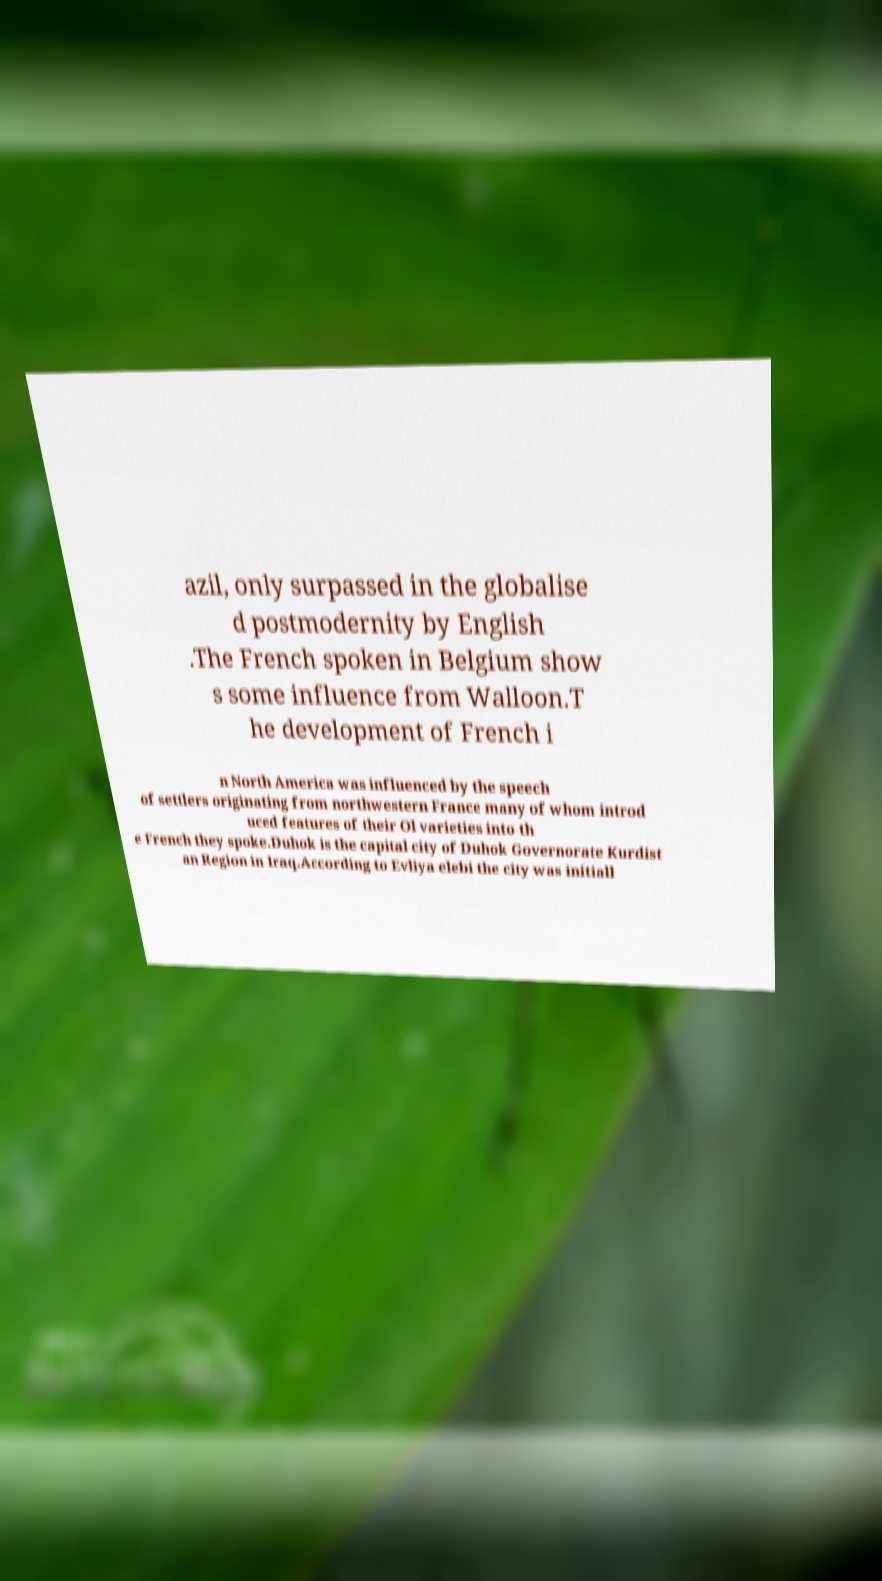Please read and relay the text visible in this image. What does it say? azil, only surpassed in the globalise d postmodernity by English .The French spoken in Belgium show s some influence from Walloon.T he development of French i n North America was influenced by the speech of settlers originating from northwestern France many of whom introd uced features of their Ol varieties into th e French they spoke.Duhok is the capital city of Duhok Governorate Kurdist an Region in Iraq.According to Evliya elebi the city was initiall 